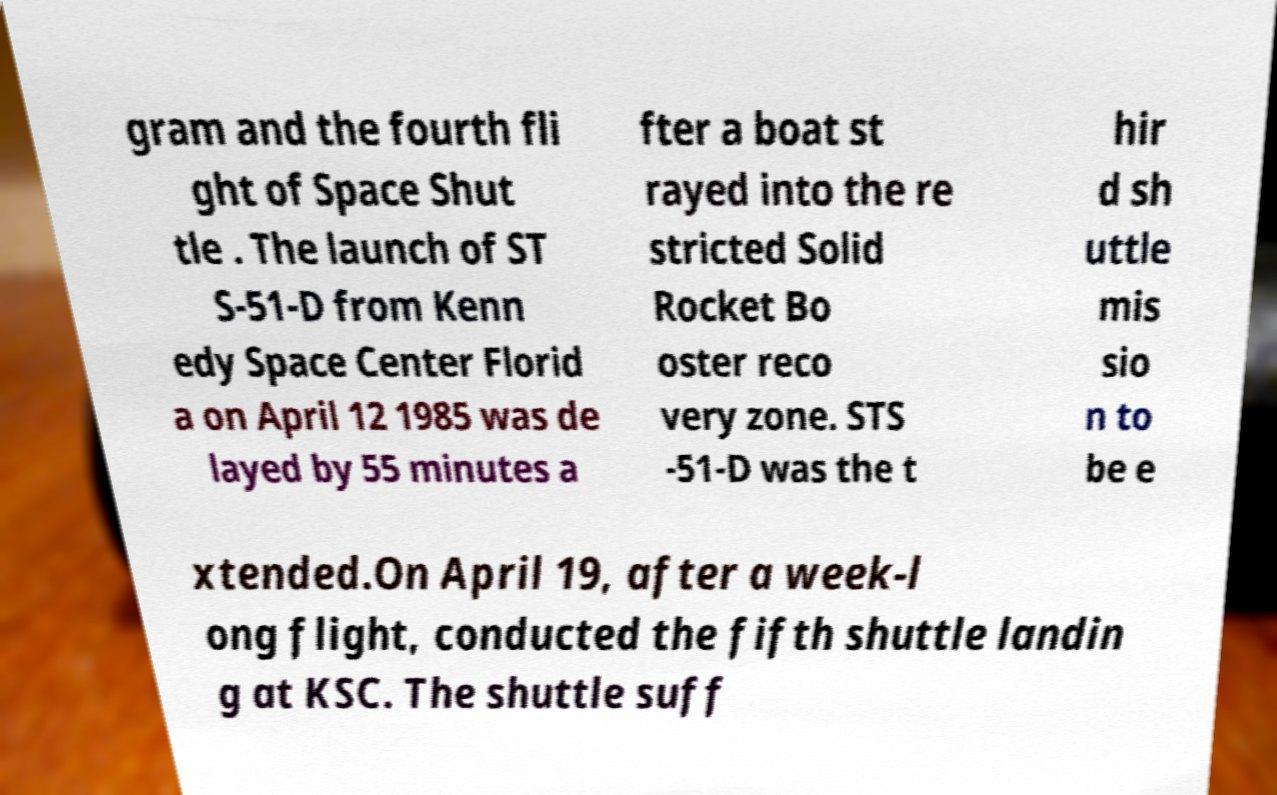Please identify and transcribe the text found in this image. gram and the fourth fli ght of Space Shut tle . The launch of ST S-51-D from Kenn edy Space Center Florid a on April 12 1985 was de layed by 55 minutes a fter a boat st rayed into the re stricted Solid Rocket Bo oster reco very zone. STS -51-D was the t hir d sh uttle mis sio n to be e xtended.On April 19, after a week-l ong flight, conducted the fifth shuttle landin g at KSC. The shuttle suff 